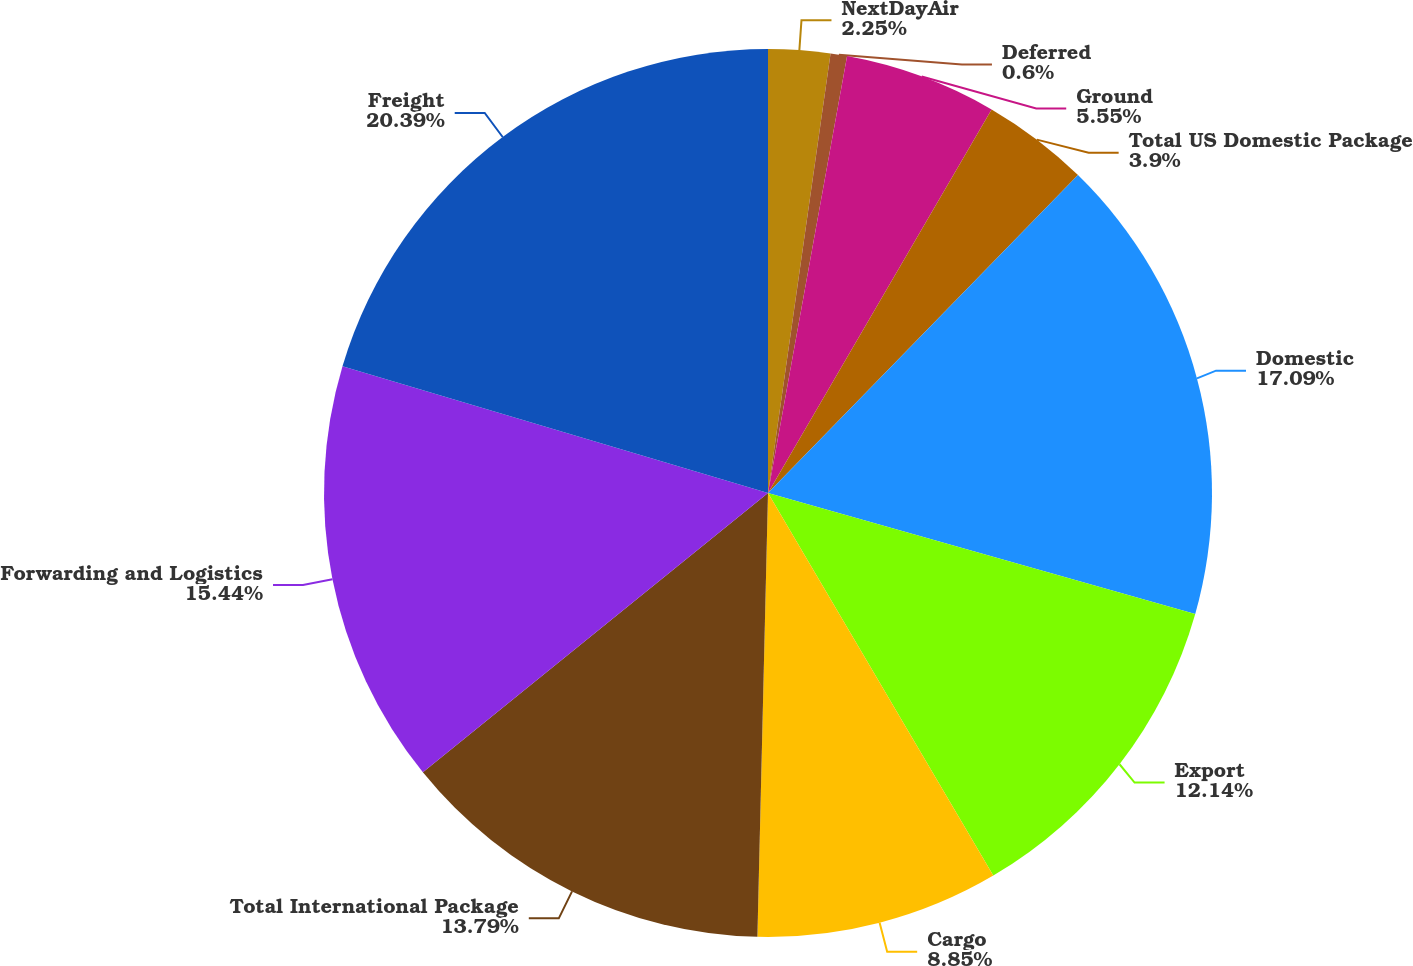Convert chart. <chart><loc_0><loc_0><loc_500><loc_500><pie_chart><fcel>NextDayAir<fcel>Deferred<fcel>Ground<fcel>Total US Domestic Package<fcel>Domestic<fcel>Export<fcel>Cargo<fcel>Total International Package<fcel>Forwarding and Logistics<fcel>Freight<nl><fcel>2.25%<fcel>0.6%<fcel>5.55%<fcel>3.9%<fcel>17.09%<fcel>12.14%<fcel>8.85%<fcel>13.79%<fcel>15.44%<fcel>20.39%<nl></chart> 